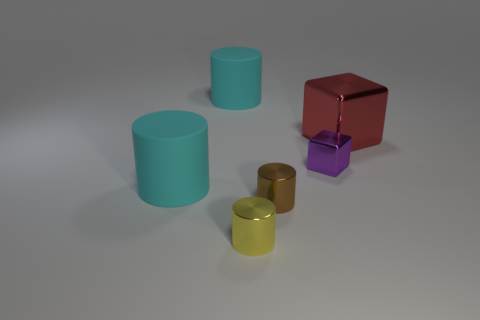Do the matte cylinder that is in front of the large red metallic thing and the cylinder that is behind the tiny purple cube have the same color?
Your answer should be very brief. Yes. There is a tiny metallic object to the right of the small brown metallic object; what color is it?
Offer a terse response. Purple. There is a block to the right of the small purple thing; does it have the same size as the cyan cylinder behind the small metal cube?
Ensure brevity in your answer.  Yes. Are there any other objects of the same size as the red object?
Keep it short and to the point. Yes. There is a matte cylinder behind the big red block; how many small cylinders are on the left side of it?
Your answer should be compact. 0. What is the small block made of?
Your response must be concise. Metal. How many small metal cubes are in front of the large cube?
Provide a succinct answer. 1. Is the color of the tiny block the same as the large metallic cube?
Provide a short and direct response. No. Are there more red shiny cylinders than big cyan cylinders?
Offer a very short reply. No. There is a shiny object that is in front of the small purple metallic cube and to the right of the tiny yellow metallic cylinder; how big is it?
Your answer should be very brief. Small. 